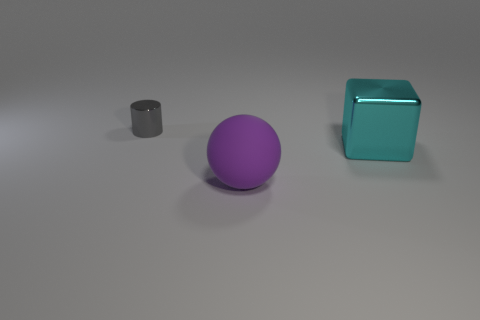Do the cyan object and the purple matte sphere have the same size?
Make the answer very short. Yes. There is a large rubber sphere; does it have the same color as the large thing that is behind the large matte thing?
Your response must be concise. No. What shape is the cyan object that is made of the same material as the small gray object?
Give a very brief answer. Cube. There is a thing on the left side of the purple thing; does it have the same shape as the large purple matte object?
Offer a very short reply. No. There is a thing in front of the metal thing that is in front of the tiny cylinder; what is its size?
Give a very brief answer. Large. There is another thing that is the same material as the big cyan object; what is its color?
Ensure brevity in your answer.  Gray. What number of purple spheres are the same size as the purple rubber object?
Provide a succinct answer. 0. How many gray things are cylinders or big metal cubes?
Offer a terse response. 1. What number of objects are tiny gray metallic objects or things that are behind the cyan block?
Your response must be concise. 1. What material is the large thing behind the big purple thing?
Your answer should be very brief. Metal. 